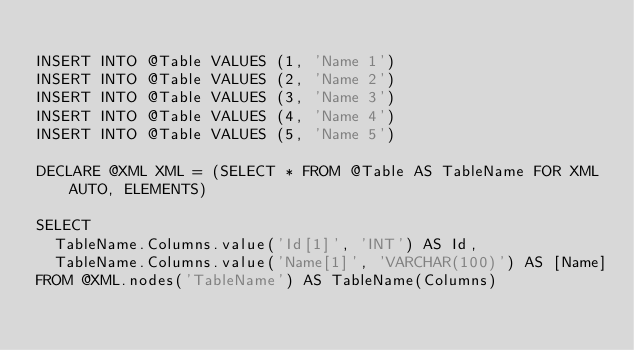Convert code to text. <code><loc_0><loc_0><loc_500><loc_500><_SQL_>
INSERT INTO @Table VALUES (1, 'Name 1')
INSERT INTO @Table VALUES (2, 'Name 2')
INSERT INTO @Table VALUES (3, 'Name 3')
INSERT INTO @Table VALUES (4, 'Name 4')
INSERT INTO @Table VALUES (5, 'Name 5')

DECLARE @XML XML = (SELECT * FROM @Table AS TableName FOR XML AUTO, ELEMENTS)

SELECT
	TableName.Columns.value('Id[1]', 'INT') AS Id,
	TableName.Columns.value('Name[1]', 'VARCHAR(100)') AS [Name]
FROM @XML.nodes('TableName') AS TableName(Columns)</code> 